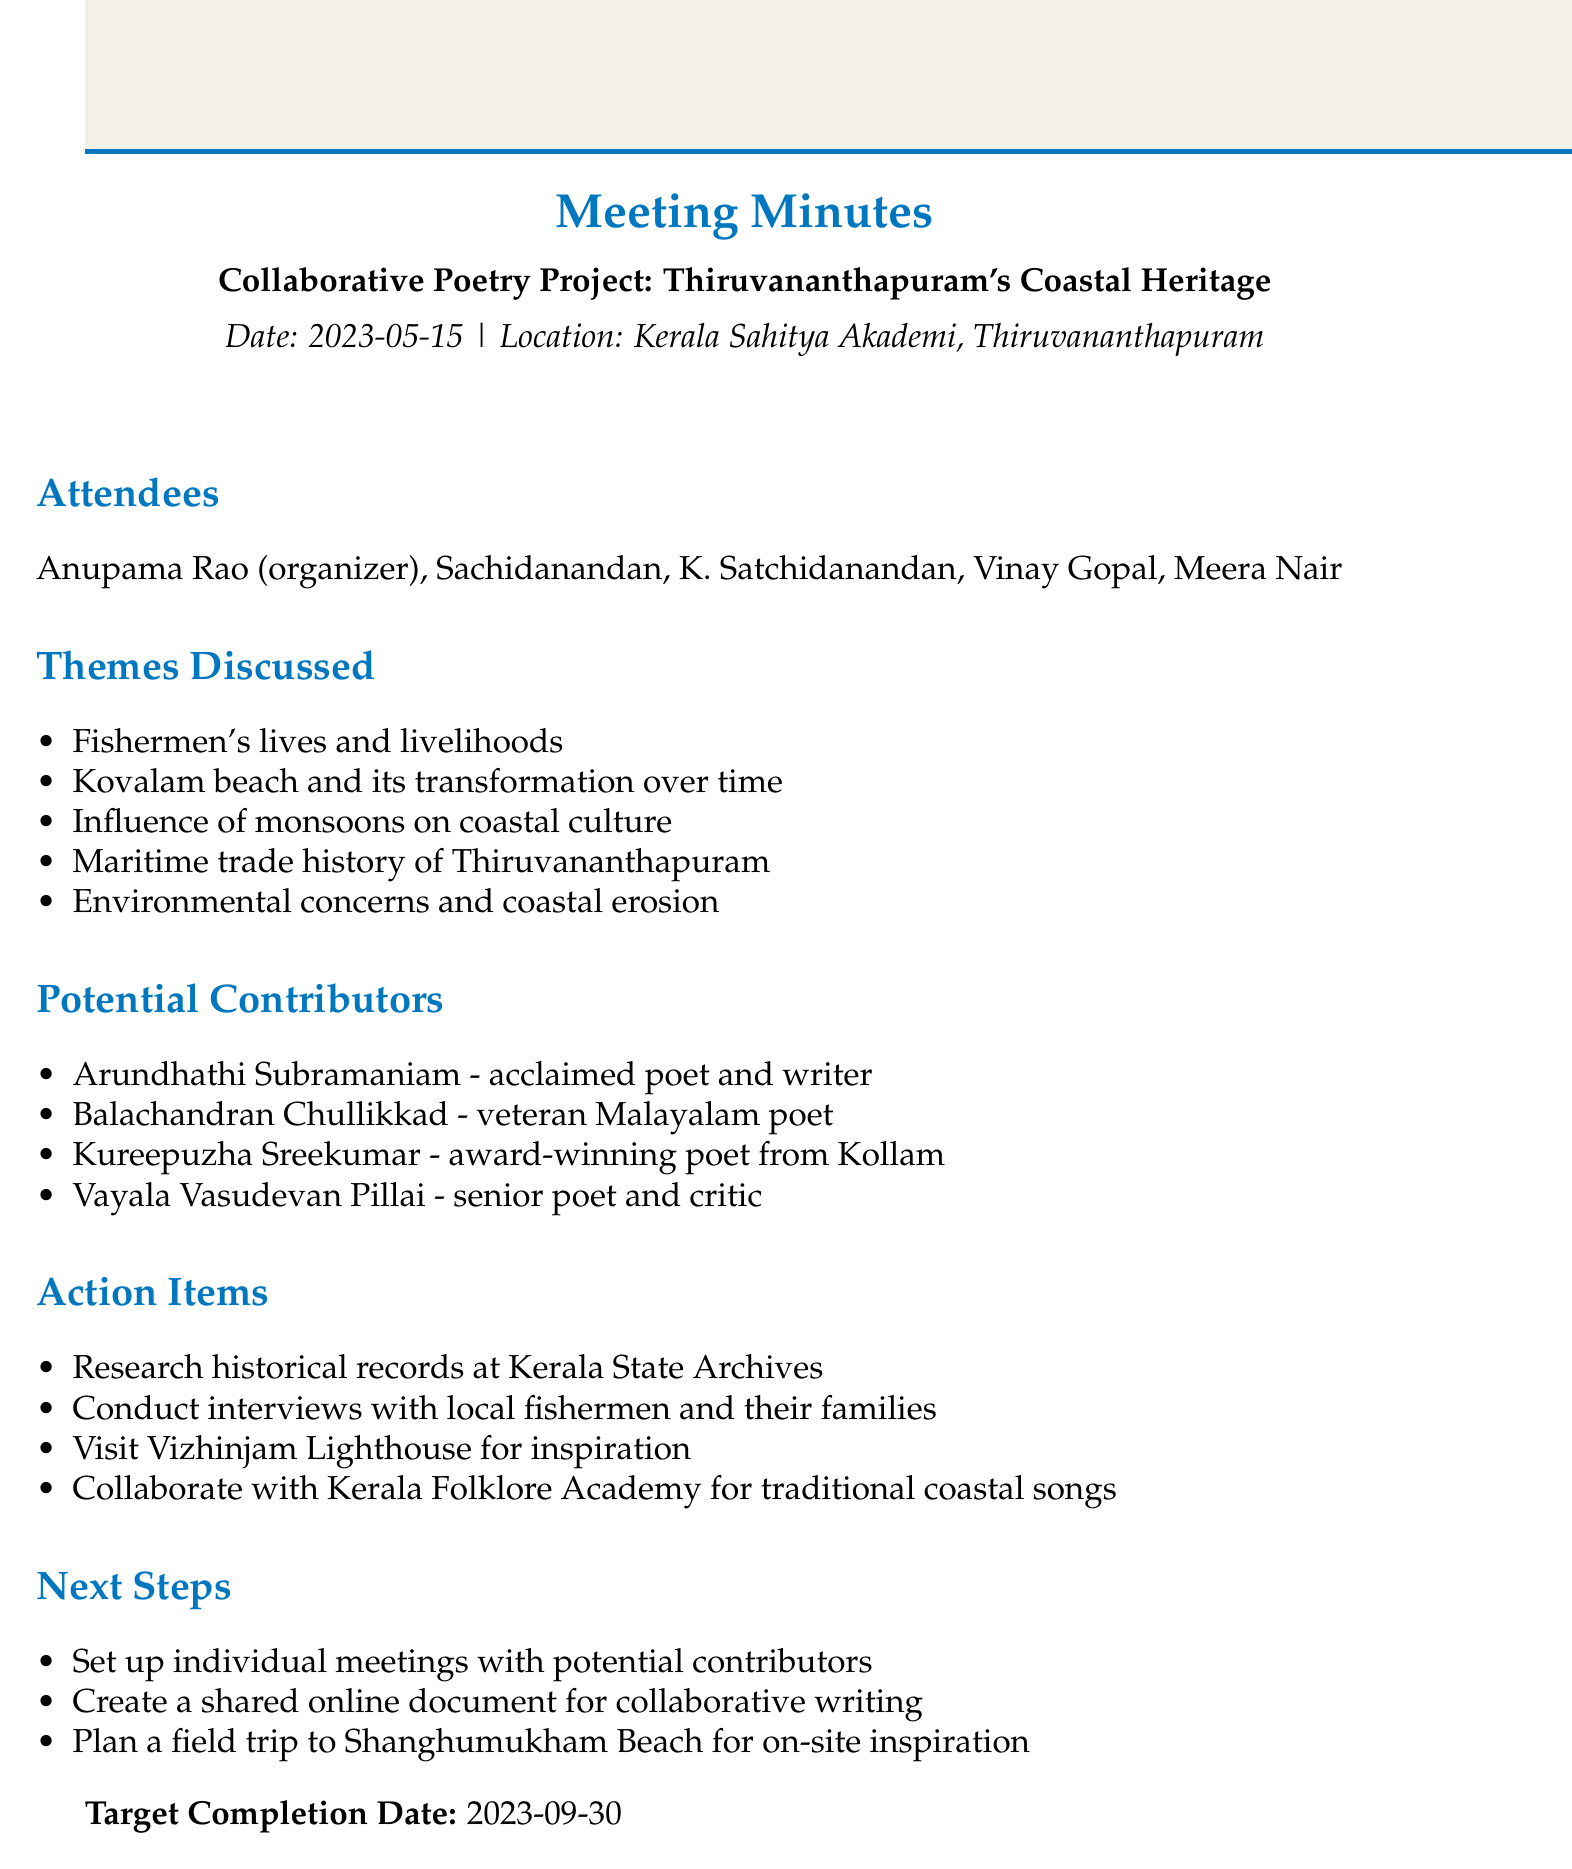What is the title of the meeting? The title of the meeting is clearly stated at the beginning of the document.
Answer: Collaborative Poetry Project: Thiruvananthapuram's Coastal Heritage When did the meeting take place? The date of the meeting is mentioned in the document.
Answer: 2023-05-15 Where was the meeting held? The location of the meeting is specified in the document.
Answer: Kerala Sahitya Akademi, Thiruvananthapuram Who is one of the potential contributors listed? The document lists potential contributors for the project.
Answer: Arundhathi Subramaniam What is one theme discussed during the meeting? Several themes are outlined in the document that were discussed during the meeting.
Answer: Fishermen's lives and livelihoods What is one action item noted from the meeting? Action items to be taken following the meeting are listed in the document.
Answer: Research historical records at Kerala State Archives What is the target completion date for the project? The target completion date is indicated in the final section of the document.
Answer: 2023-09-30 What step involves meeting contributors? The next steps section includes information about future actions.
Answer: Set up individual meetings with potential contributors How many attendees were present at the meeting? The number of attendees can be counted from the list provided.
Answer: 5 